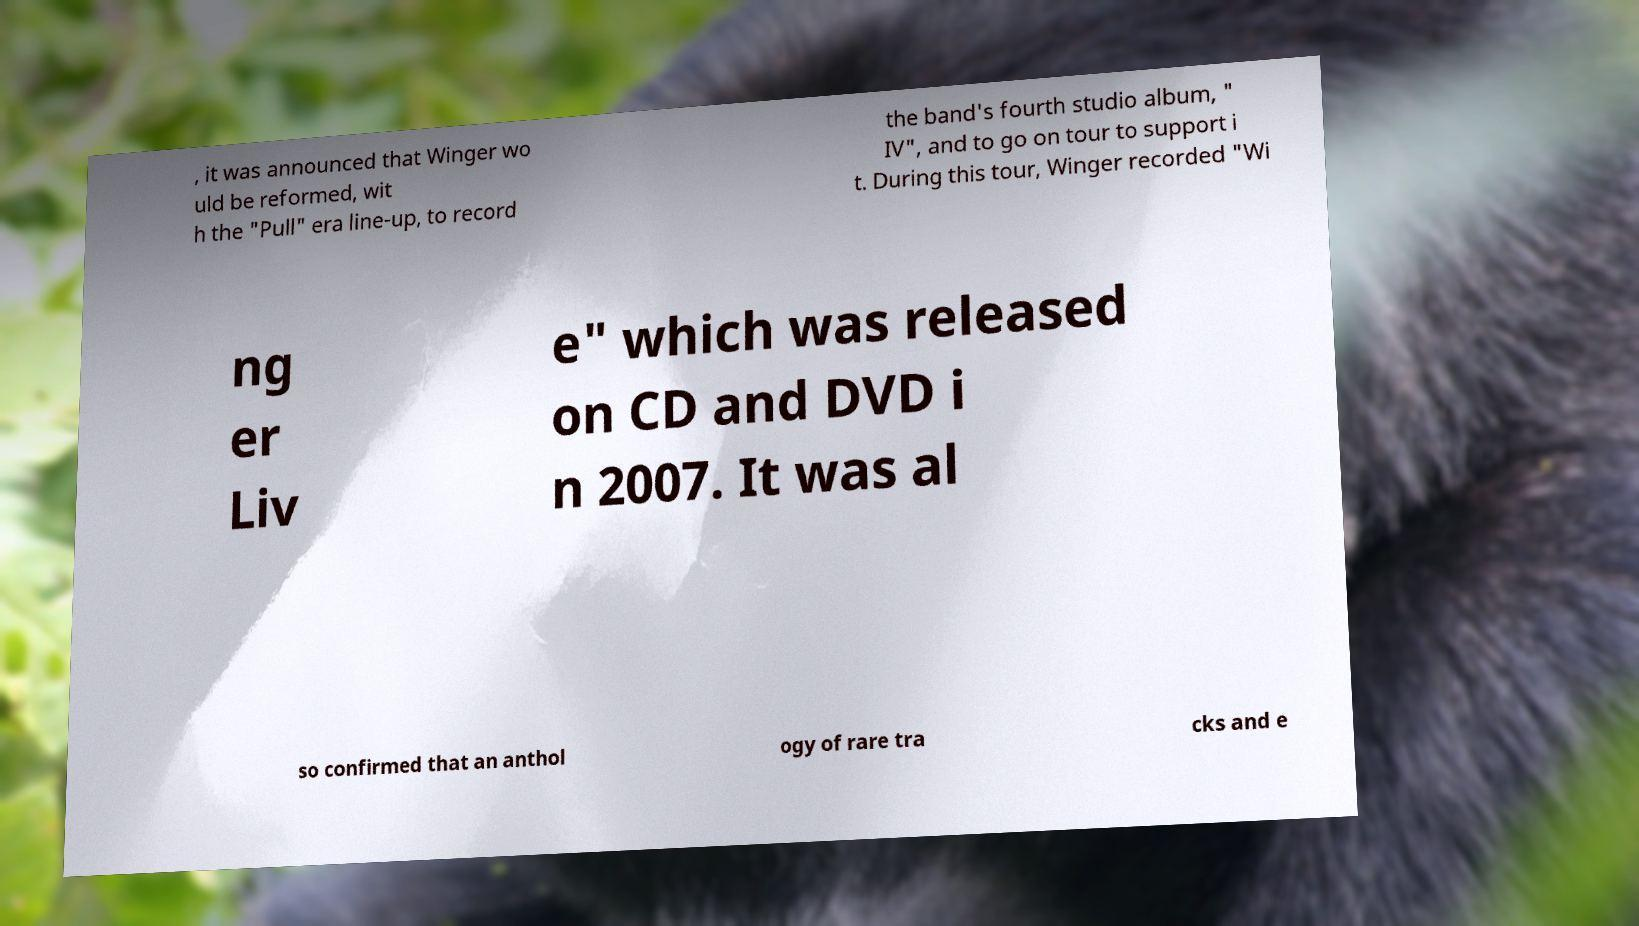What messages or text are displayed in this image? I need them in a readable, typed format. , it was announced that Winger wo uld be reformed, wit h the "Pull" era line-up, to record the band's fourth studio album, " IV", and to go on tour to support i t. During this tour, Winger recorded "Wi ng er Liv e" which was released on CD and DVD i n 2007. It was al so confirmed that an anthol ogy of rare tra cks and e 